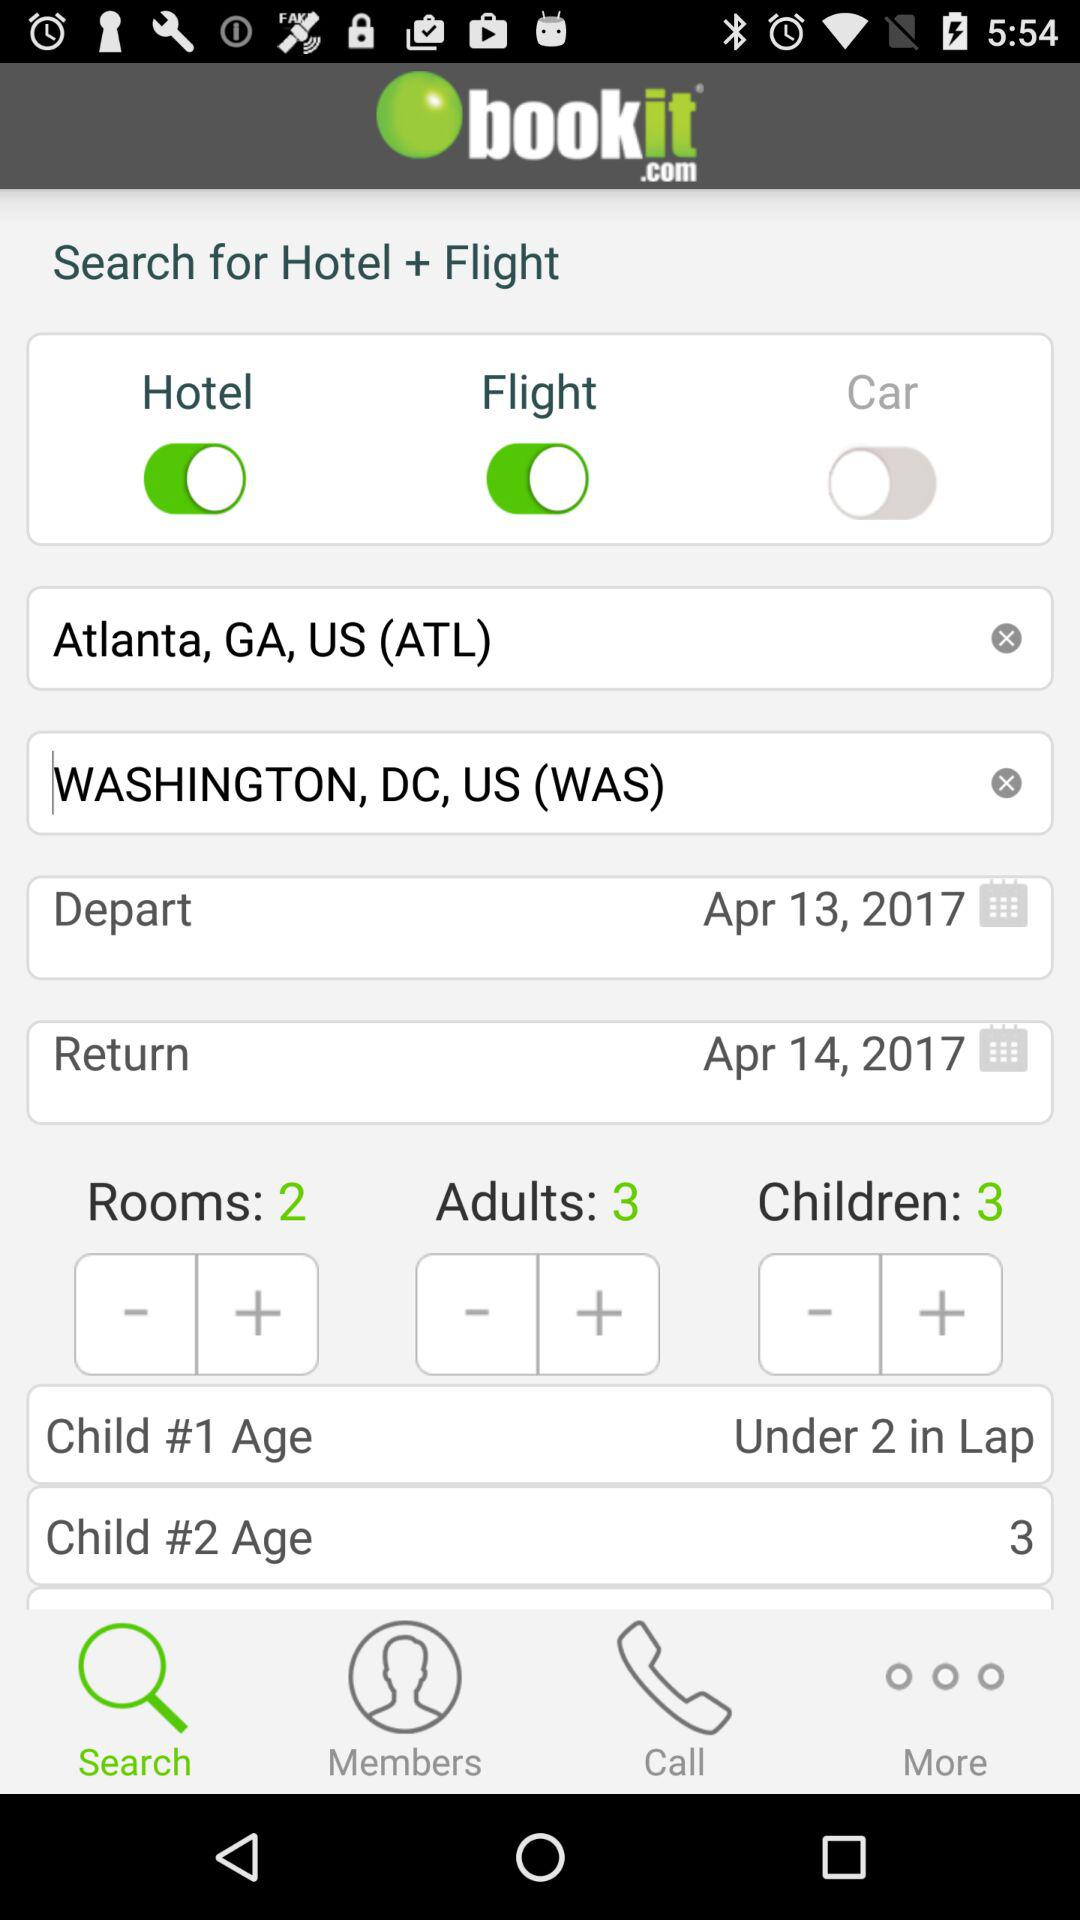What is the departure date? The departure date is April 13, 2017. 